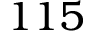<formula> <loc_0><loc_0><loc_500><loc_500>1 1 5</formula> 